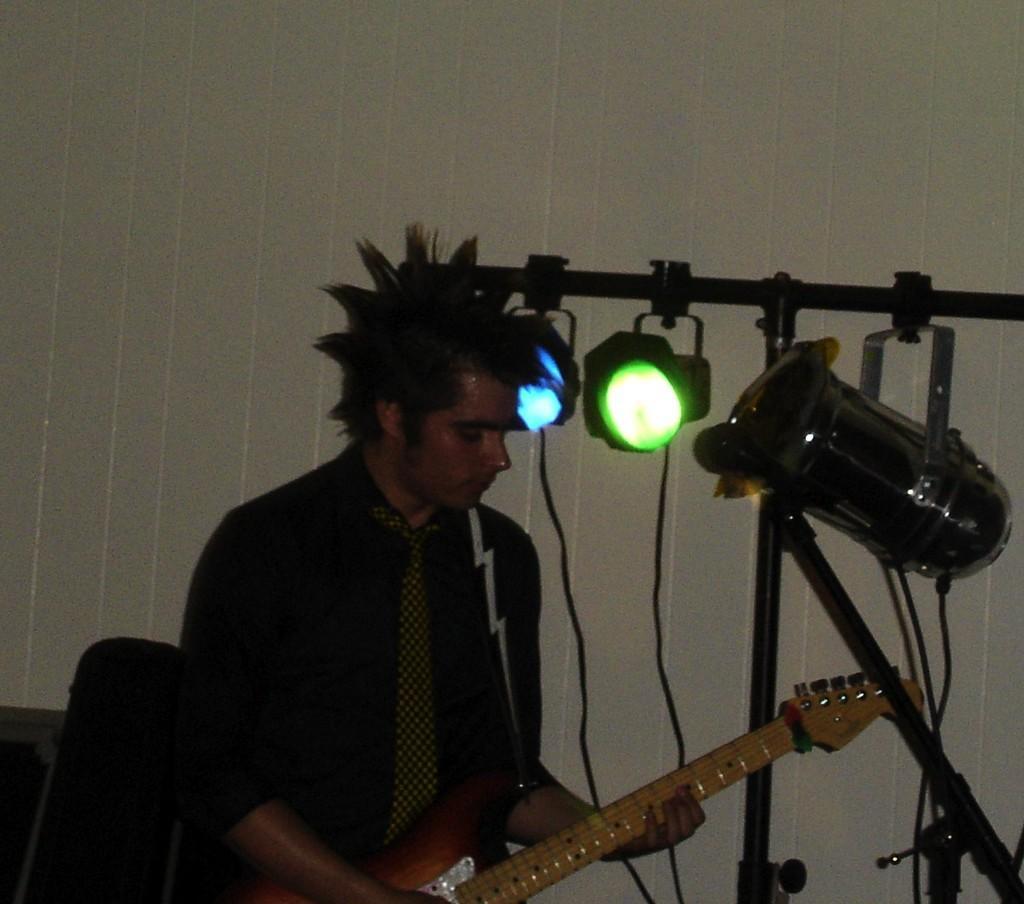Please provide a concise description of this image. In this picture we can see a man who is playing guitar. On the background there is a wall and these are the lights. 